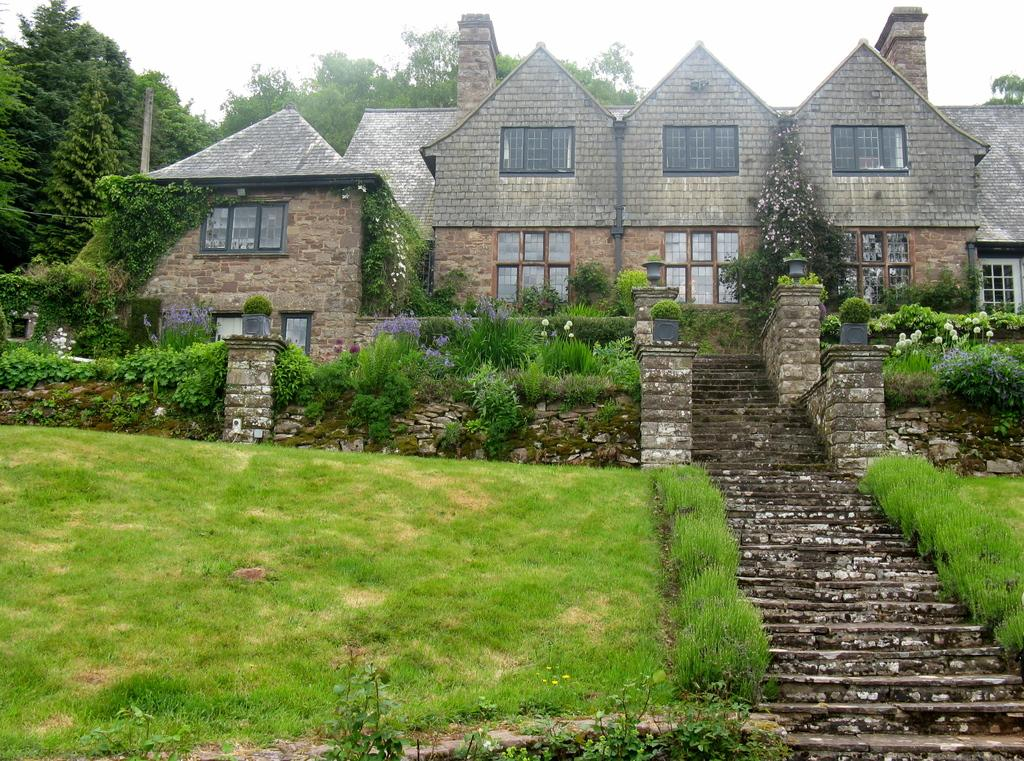What type of vegetation can be seen in the image? There are plants and grass in the image. What architectural feature is present in the image? There are stairs in the image. What can be seen in the background of the image? There are houses and a clear sky visible in the background of the image. What type of picture is hanging on the wall in the image? There is no picture hanging on the wall in the image; it only features plants, grass, stairs, houses, and a clear sky. Can you hear any bells ringing in the image? There are no bells present in the image, so it is not possible to hear them ringing. 